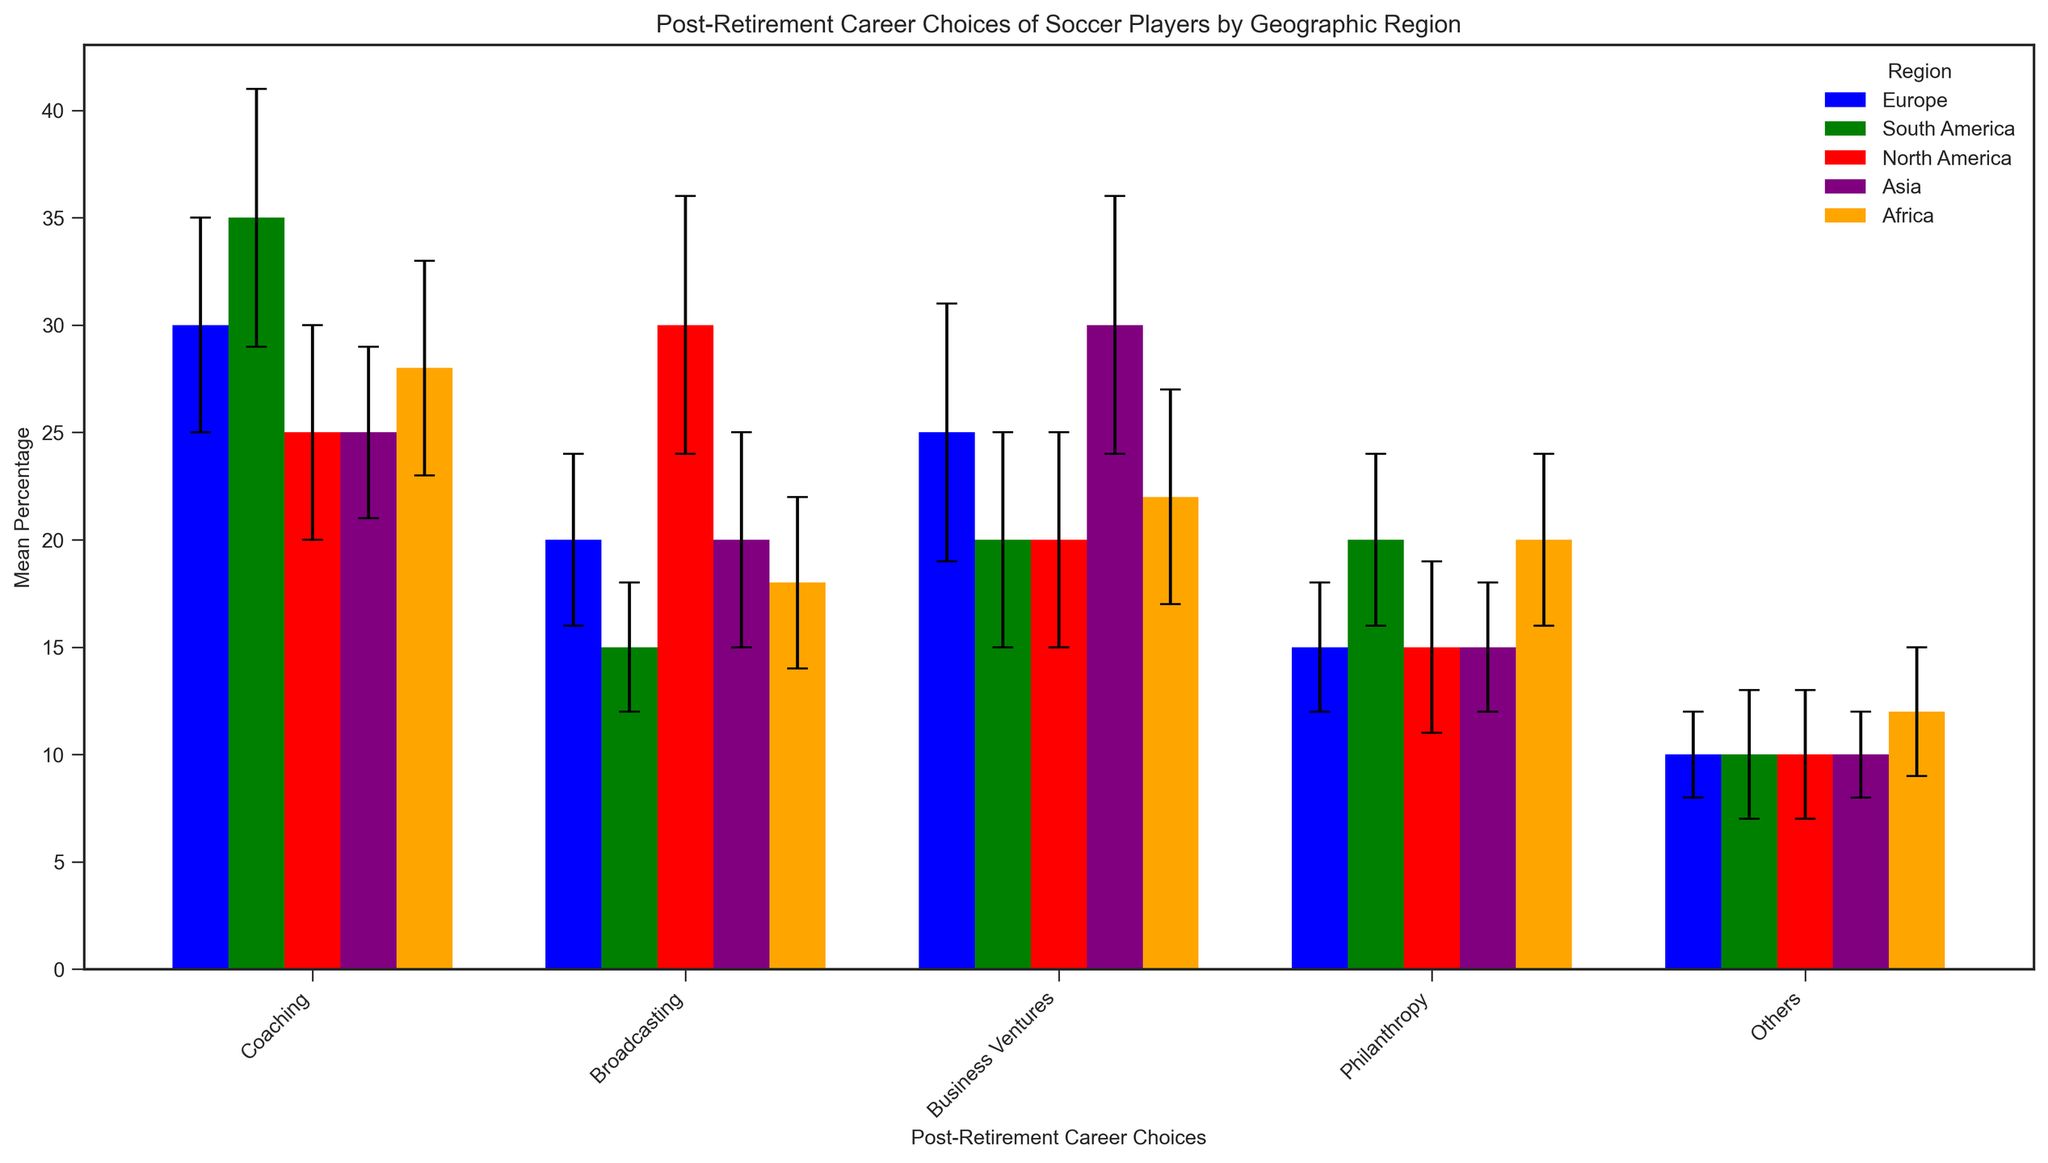Which region shows the highest mean percentage of players entering coaching? First, identify the regions and their respective coaching bars by color. Then compare the heights and check their exact values. Europe has a mean percentage of 30%, South America 35%, North America 25%, Asia 25%, and Africa 28%. So, South America is the highest.
Answer: South America Which post-retirement career choice in North America shows the greatest standard deviation? Look at the error bars (standard deviation) for each post-retirement career choice within the North America group. Broadcasting has the largest error bar with a standard deviation of 6.
Answer: Broadcasting What is the combined mean percentage of players entering philanthropy in Europe and Asia? Identify the mean percentages for philanthropy in Europe and Asia. Europe has 15% and Asia also 15%. The combined mean percentage is 15% + 15% = 30%.
Answer: 30% Which career choice shows the most variability (highest standard deviation) across the regions? Evaluate the standard deviations (error bars) for each career choice across all regions. Business Ventures in Europe and Asia shows the highest variability with a standard deviation of 6 in both regions.
Answer: Business Ventures Is there any post-retirement career choice where all regions have almost the same mean percentage? Compare the mean percentages of each career across all regions. The 'Others' category stands out; they all hover around 10%-12% across all regions.
Answer: Others In which region do players most often pursue broadcasting as a post-retirement career? Check the heights of the bars for Broadcasting across all regions. North America has the highest bar with a mean percentage of 30%.
Answer: North America What is the difference in the mean percentage of players who enter business ventures between South America and Asia? Find the mean percentages for business ventures in South America (20%) and Asia (30%). The difference is 30% - 20% = 10%.
Answer: 10% Which region has the lowest mean percentage of players entering philanthropy, and what is that percentage? Compare the heights of the philanthropy bars across the regions. Europe has the lowest with a mean percentage of 15%.
Answer: Europe, 15% How does the mean percentage of players entering coaching in Africa compare to that in North America? Look at the coaching bars for Africa and North America. Africa has a mean percentage of 28%, while North America has 25%. Africa's percentage is higher.
Answer: Africa is higher 